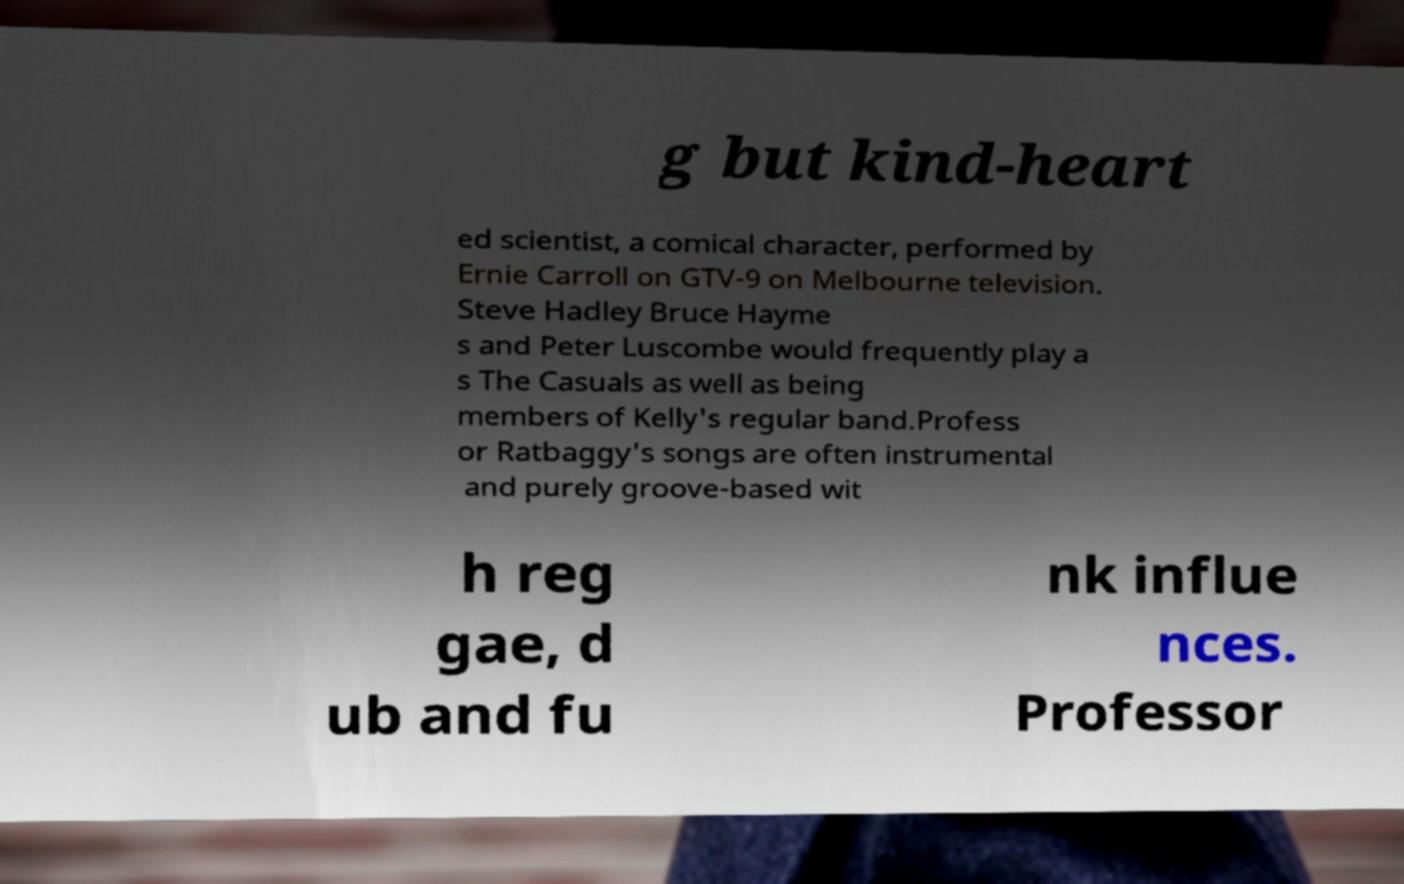Could you assist in decoding the text presented in this image and type it out clearly? g but kind-heart ed scientist, a comical character, performed by Ernie Carroll on GTV-9 on Melbourne television. Steve Hadley Bruce Hayme s and Peter Luscombe would frequently play a s The Casuals as well as being members of Kelly's regular band.Profess or Ratbaggy's songs are often instrumental and purely groove-based wit h reg gae, d ub and fu nk influe nces. Professor 